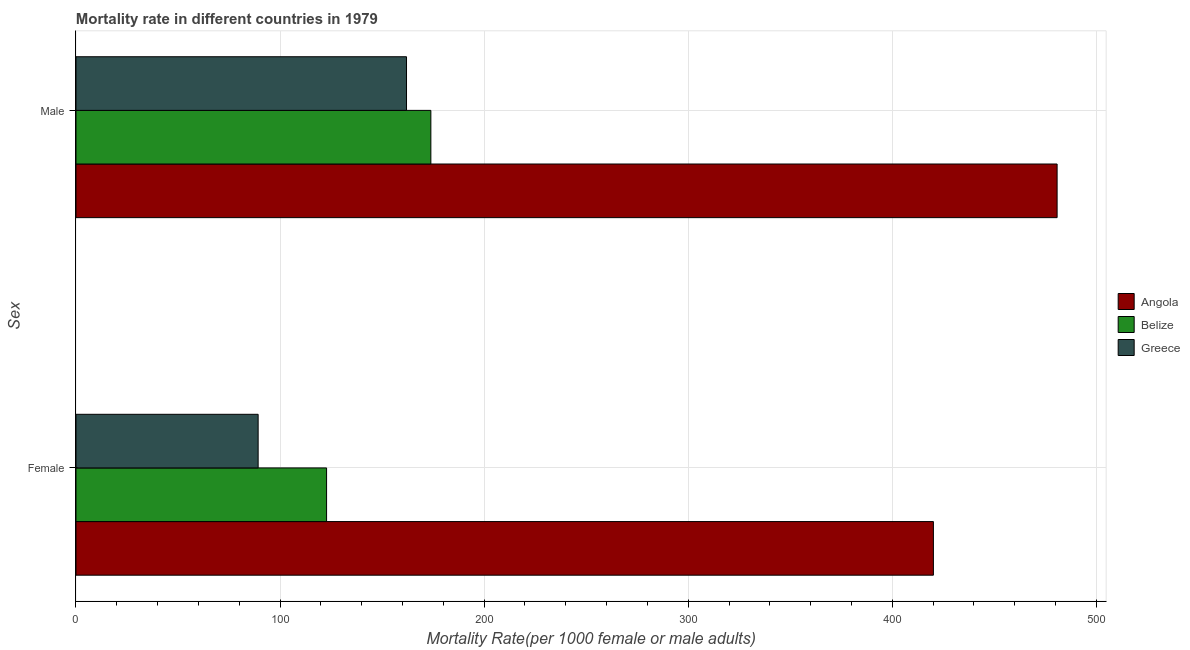How many different coloured bars are there?
Your answer should be very brief. 3. How many groups of bars are there?
Offer a terse response. 2. How many bars are there on the 2nd tick from the bottom?
Make the answer very short. 3. What is the female mortality rate in Belize?
Offer a terse response. 122.78. Across all countries, what is the maximum male mortality rate?
Your answer should be very brief. 480.73. Across all countries, what is the minimum male mortality rate?
Offer a terse response. 161.95. In which country was the male mortality rate maximum?
Offer a terse response. Angola. What is the total male mortality rate in the graph?
Ensure brevity in your answer.  816.56. What is the difference between the female mortality rate in Belize and that in Angola?
Offer a terse response. -297.33. What is the difference between the male mortality rate in Greece and the female mortality rate in Belize?
Provide a short and direct response. 39.17. What is the average male mortality rate per country?
Ensure brevity in your answer.  272.19. What is the difference between the male mortality rate and female mortality rate in Angola?
Your response must be concise. 60.61. In how many countries, is the female mortality rate greater than 60 ?
Make the answer very short. 3. What is the ratio of the female mortality rate in Angola to that in Greece?
Your response must be concise. 4.71. In how many countries, is the female mortality rate greater than the average female mortality rate taken over all countries?
Provide a succinct answer. 1. What does the 1st bar from the top in Male represents?
Ensure brevity in your answer.  Greece. What does the 2nd bar from the bottom in Female represents?
Provide a short and direct response. Belize. How many bars are there?
Keep it short and to the point. 6. Are all the bars in the graph horizontal?
Provide a short and direct response. Yes. Does the graph contain any zero values?
Provide a short and direct response. No. How many legend labels are there?
Offer a very short reply. 3. What is the title of the graph?
Your answer should be very brief. Mortality rate in different countries in 1979. What is the label or title of the X-axis?
Give a very brief answer. Mortality Rate(per 1000 female or male adults). What is the label or title of the Y-axis?
Offer a terse response. Sex. What is the Mortality Rate(per 1000 female or male adults) in Angola in Female?
Provide a short and direct response. 420.11. What is the Mortality Rate(per 1000 female or male adults) in Belize in Female?
Your answer should be compact. 122.78. What is the Mortality Rate(per 1000 female or male adults) in Greece in Female?
Offer a very short reply. 89.25. What is the Mortality Rate(per 1000 female or male adults) in Angola in Male?
Provide a short and direct response. 480.73. What is the Mortality Rate(per 1000 female or male adults) in Belize in Male?
Ensure brevity in your answer.  173.88. What is the Mortality Rate(per 1000 female or male adults) in Greece in Male?
Your response must be concise. 161.95. Across all Sex, what is the maximum Mortality Rate(per 1000 female or male adults) of Angola?
Make the answer very short. 480.73. Across all Sex, what is the maximum Mortality Rate(per 1000 female or male adults) of Belize?
Provide a succinct answer. 173.88. Across all Sex, what is the maximum Mortality Rate(per 1000 female or male adults) of Greece?
Offer a very short reply. 161.95. Across all Sex, what is the minimum Mortality Rate(per 1000 female or male adults) in Angola?
Make the answer very short. 420.11. Across all Sex, what is the minimum Mortality Rate(per 1000 female or male adults) of Belize?
Your answer should be compact. 122.78. Across all Sex, what is the minimum Mortality Rate(per 1000 female or male adults) of Greece?
Your response must be concise. 89.25. What is the total Mortality Rate(per 1000 female or male adults) in Angola in the graph?
Your response must be concise. 900.84. What is the total Mortality Rate(per 1000 female or male adults) of Belize in the graph?
Offer a terse response. 296.67. What is the total Mortality Rate(per 1000 female or male adults) of Greece in the graph?
Offer a terse response. 251.2. What is the difference between the Mortality Rate(per 1000 female or male adults) in Angola in Female and that in Male?
Give a very brief answer. -60.61. What is the difference between the Mortality Rate(per 1000 female or male adults) of Belize in Female and that in Male?
Provide a short and direct response. -51.1. What is the difference between the Mortality Rate(per 1000 female or male adults) of Greece in Female and that in Male?
Your response must be concise. -72.7. What is the difference between the Mortality Rate(per 1000 female or male adults) of Angola in Female and the Mortality Rate(per 1000 female or male adults) of Belize in Male?
Provide a short and direct response. 246.23. What is the difference between the Mortality Rate(per 1000 female or male adults) in Angola in Female and the Mortality Rate(per 1000 female or male adults) in Greece in Male?
Give a very brief answer. 258.16. What is the difference between the Mortality Rate(per 1000 female or male adults) in Belize in Female and the Mortality Rate(per 1000 female or male adults) in Greece in Male?
Your answer should be very brief. -39.17. What is the average Mortality Rate(per 1000 female or male adults) of Angola per Sex?
Keep it short and to the point. 450.42. What is the average Mortality Rate(per 1000 female or male adults) in Belize per Sex?
Ensure brevity in your answer.  148.33. What is the average Mortality Rate(per 1000 female or male adults) in Greece per Sex?
Provide a succinct answer. 125.6. What is the difference between the Mortality Rate(per 1000 female or male adults) of Angola and Mortality Rate(per 1000 female or male adults) of Belize in Female?
Offer a terse response. 297.33. What is the difference between the Mortality Rate(per 1000 female or male adults) in Angola and Mortality Rate(per 1000 female or male adults) in Greece in Female?
Your answer should be compact. 330.86. What is the difference between the Mortality Rate(per 1000 female or male adults) in Belize and Mortality Rate(per 1000 female or male adults) in Greece in Female?
Offer a very short reply. 33.53. What is the difference between the Mortality Rate(per 1000 female or male adults) of Angola and Mortality Rate(per 1000 female or male adults) of Belize in Male?
Ensure brevity in your answer.  306.84. What is the difference between the Mortality Rate(per 1000 female or male adults) of Angola and Mortality Rate(per 1000 female or male adults) of Greece in Male?
Make the answer very short. 318.77. What is the difference between the Mortality Rate(per 1000 female or male adults) of Belize and Mortality Rate(per 1000 female or male adults) of Greece in Male?
Your answer should be compact. 11.93. What is the ratio of the Mortality Rate(per 1000 female or male adults) of Angola in Female to that in Male?
Your answer should be compact. 0.87. What is the ratio of the Mortality Rate(per 1000 female or male adults) in Belize in Female to that in Male?
Offer a very short reply. 0.71. What is the ratio of the Mortality Rate(per 1000 female or male adults) in Greece in Female to that in Male?
Your answer should be very brief. 0.55. What is the difference between the highest and the second highest Mortality Rate(per 1000 female or male adults) in Angola?
Make the answer very short. 60.61. What is the difference between the highest and the second highest Mortality Rate(per 1000 female or male adults) in Belize?
Offer a terse response. 51.1. What is the difference between the highest and the second highest Mortality Rate(per 1000 female or male adults) of Greece?
Make the answer very short. 72.7. What is the difference between the highest and the lowest Mortality Rate(per 1000 female or male adults) in Angola?
Your answer should be compact. 60.61. What is the difference between the highest and the lowest Mortality Rate(per 1000 female or male adults) of Belize?
Give a very brief answer. 51.1. What is the difference between the highest and the lowest Mortality Rate(per 1000 female or male adults) of Greece?
Ensure brevity in your answer.  72.7. 